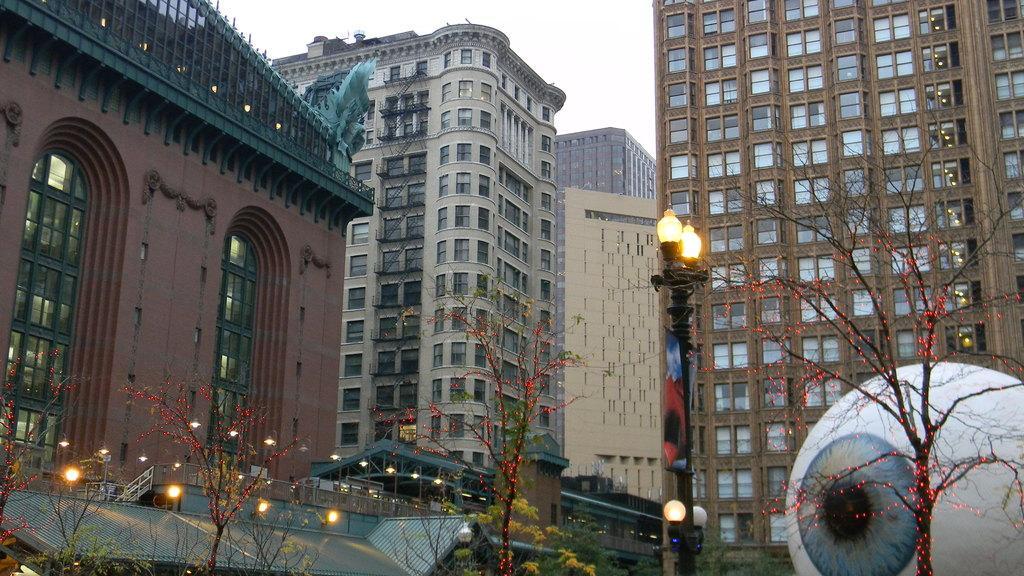In one or two sentences, can you explain what this image depicts? In this picture there are buildings and trees and there are street lights. On the right side of the image it looks like a sculpture. On the left side of the image there is a staircase. At the top there is sky and there are lights on the trees. 